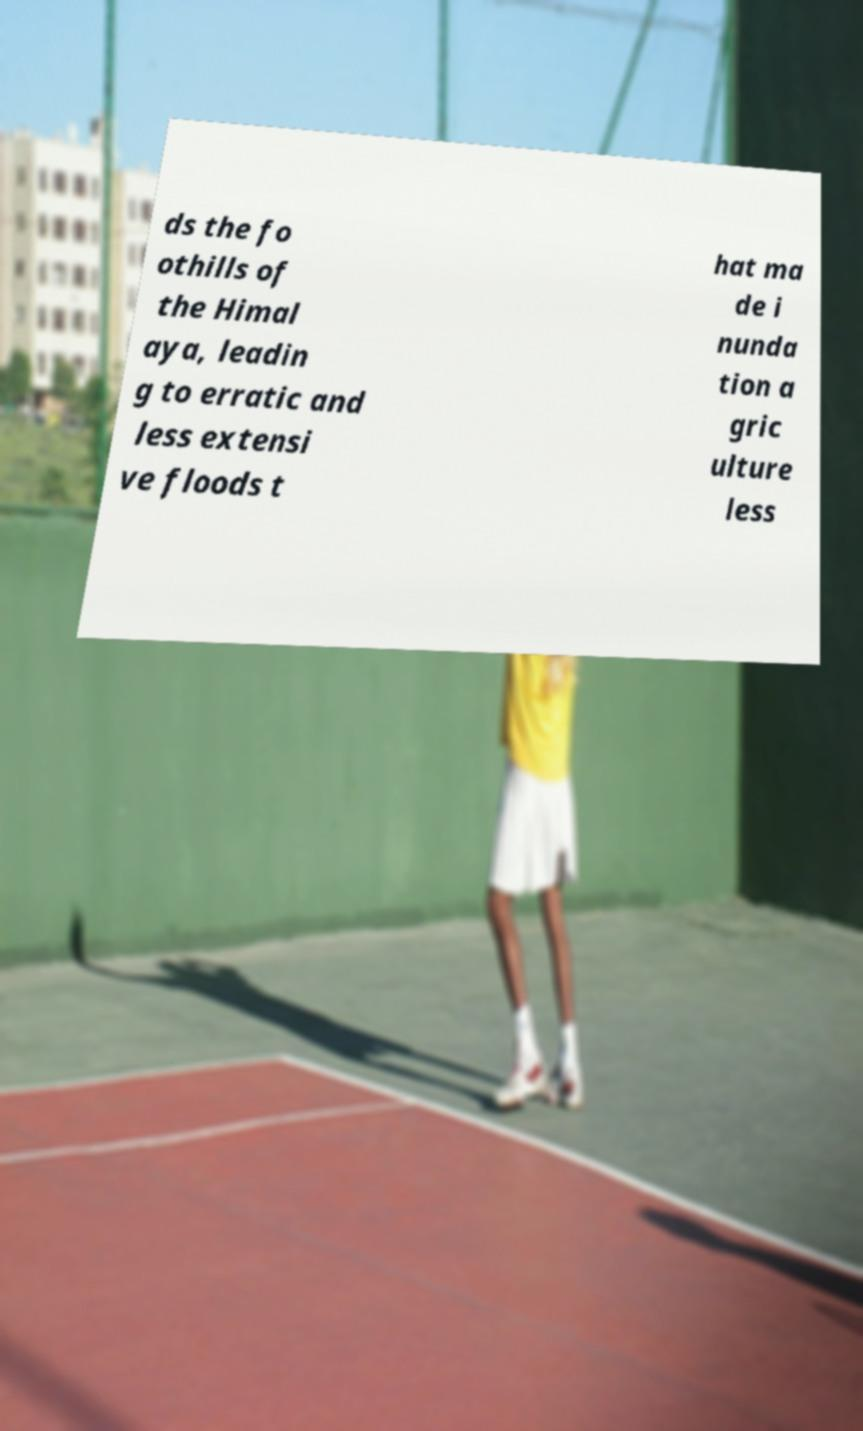I need the written content from this picture converted into text. Can you do that? ds the fo othills of the Himal aya, leadin g to erratic and less extensi ve floods t hat ma de i nunda tion a gric ulture less 